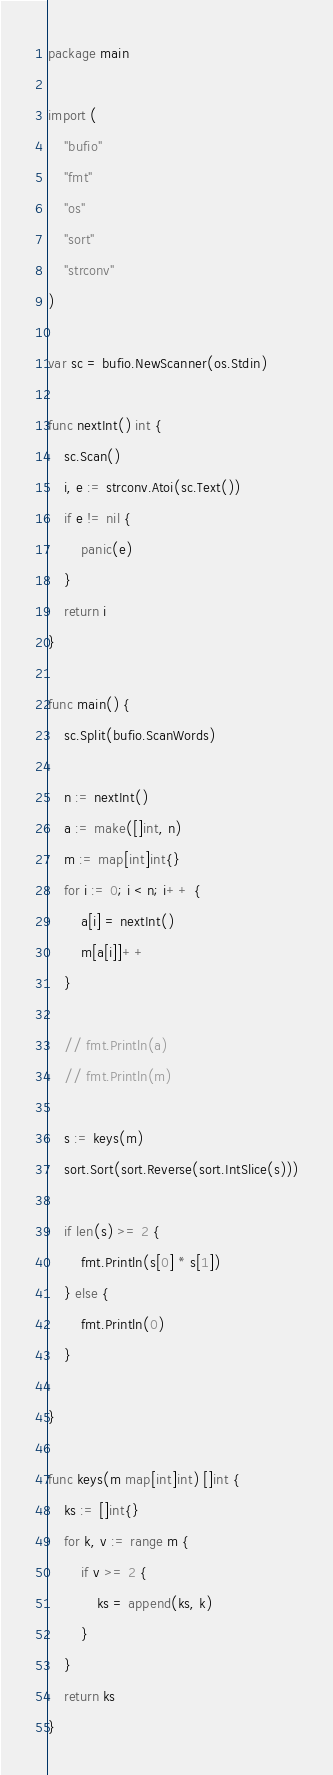<code> <loc_0><loc_0><loc_500><loc_500><_Go_>package main

import (
	"bufio"
	"fmt"
	"os"
	"sort"
	"strconv"
)

var sc = bufio.NewScanner(os.Stdin)

func nextInt() int {
	sc.Scan()
	i, e := strconv.Atoi(sc.Text())
	if e != nil {
		panic(e)
	}
	return i
}

func main() {
	sc.Split(bufio.ScanWords)

	n := nextInt()
	a := make([]int, n)
	m := map[int]int{}
	for i := 0; i < n; i++ {
		a[i] = nextInt()
		m[a[i]]++
	}

	// fmt.Println(a)
	// fmt.Println(m)

	s := keys(m)
	sort.Sort(sort.Reverse(sort.IntSlice(s)))

	if len(s) >= 2 {
		fmt.Println(s[0] * s[1])
	} else {
		fmt.Println(0)
	}

}

func keys(m map[int]int) []int {
	ks := []int{}
	for k, v := range m {
		if v >= 2 {
			ks = append(ks, k)
		}
	}
	return ks
}
</code> 